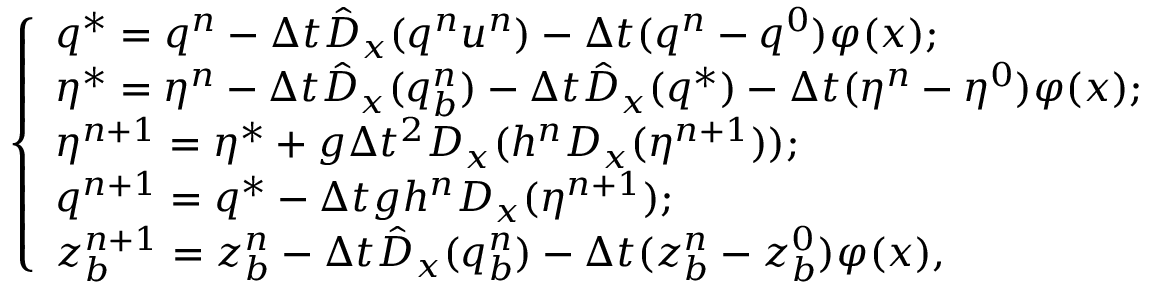Convert formula to latex. <formula><loc_0><loc_0><loc_500><loc_500>\left \{ \begin{array} { l l } { q ^ { * } = q ^ { n } - \Delta t \hat { D } _ { x } ( q ^ { n } u ^ { n } ) - \Delta t ( q ^ { n } - q ^ { 0 } ) \varphi ( x ) ; } \\ { \eta ^ { * } = \eta ^ { n } - \Delta t \hat { D } _ { x } ( q _ { b } ^ { n } ) - \Delta t \hat { D } _ { x } ( q ^ { * } ) - \Delta t ( \eta ^ { n } - \eta ^ { 0 } ) \varphi ( x ) ; } \\ { \eta ^ { n + 1 } = \eta ^ { * } + g \Delta t ^ { 2 } D _ { x } ( h ^ { n } D _ { x } ( \eta ^ { n + 1 } ) ) ; } \\ { q ^ { n + 1 } = q ^ { * } - \Delta t g h ^ { n } D _ { x } ( \eta ^ { n + 1 } ) ; } \\ { z _ { b } ^ { n + 1 } = z _ { b } ^ { n } - \Delta t \hat { D } _ { x } ( q _ { b } ^ { n } ) - \Delta t ( z _ { b } ^ { n } - z _ { b } ^ { 0 } ) \varphi ( x ) , } \end{array}</formula> 